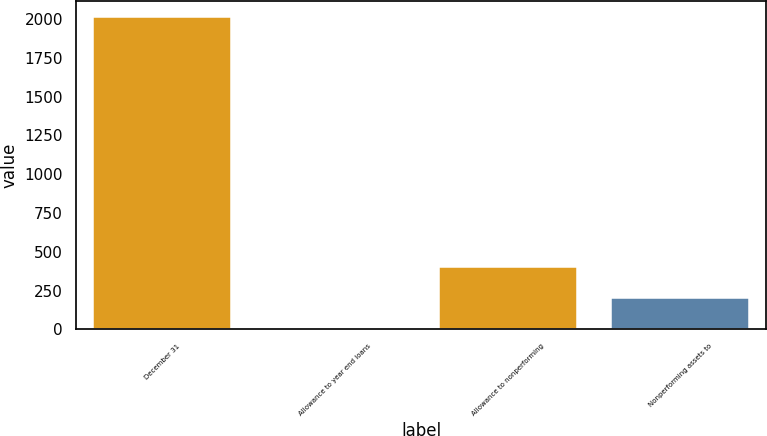Convert chart to OTSL. <chart><loc_0><loc_0><loc_500><loc_500><bar_chart><fcel>December 31<fcel>Allowance to year end loans<fcel>Allowance to nonperforming<fcel>Nonperforming assets to<nl><fcel>2012<fcel>0.52<fcel>402.82<fcel>201.67<nl></chart> 